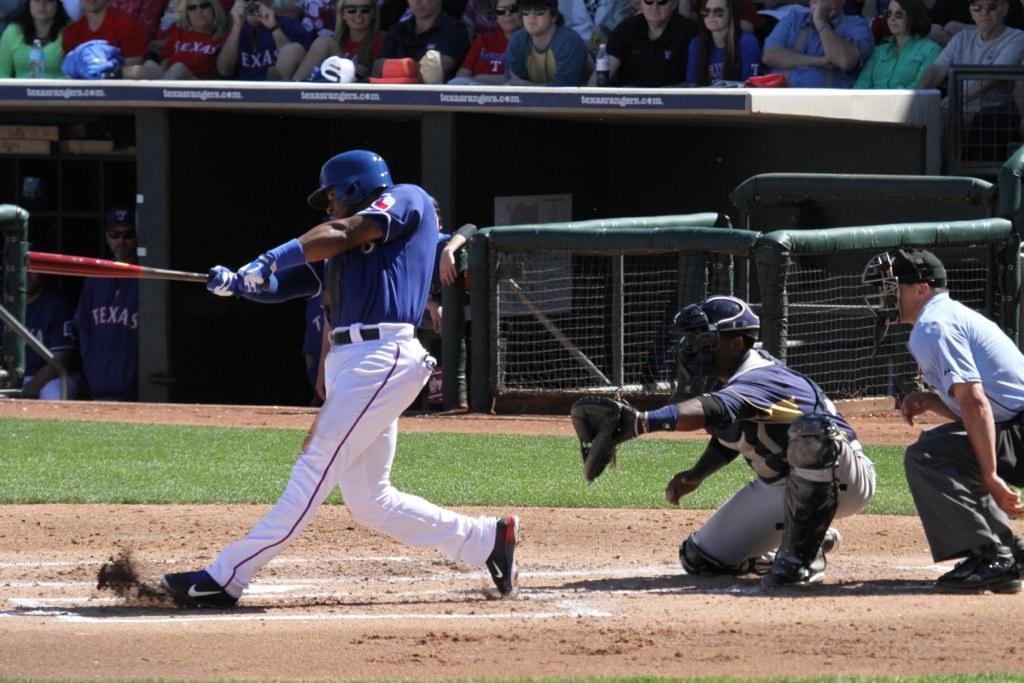<image>
Render a clear and concise summary of the photo. Man getting ready to swing at a ball as fans wearing Texas shirts are watching in the audience. 